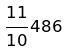<formula> <loc_0><loc_0><loc_500><loc_500>\frac { 1 1 } { 1 0 } 4 8 6</formula> 